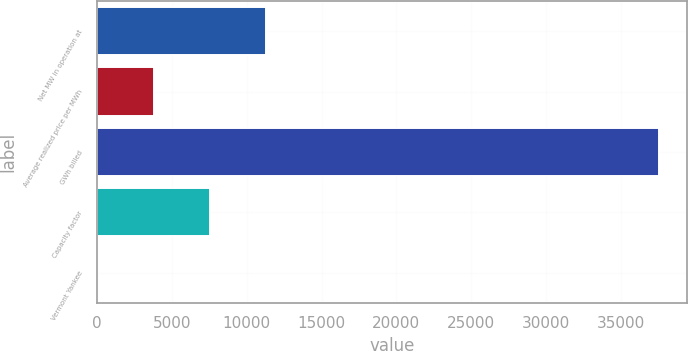Convert chart. <chart><loc_0><loc_0><loc_500><loc_500><bar_chart><fcel>Net MW in operation at<fcel>Average realized price per MWh<fcel>GWh billed<fcel>Capacity factor<fcel>Vermont Yankee<nl><fcel>11287.8<fcel>3778.6<fcel>37570<fcel>7533.2<fcel>24<nl></chart> 